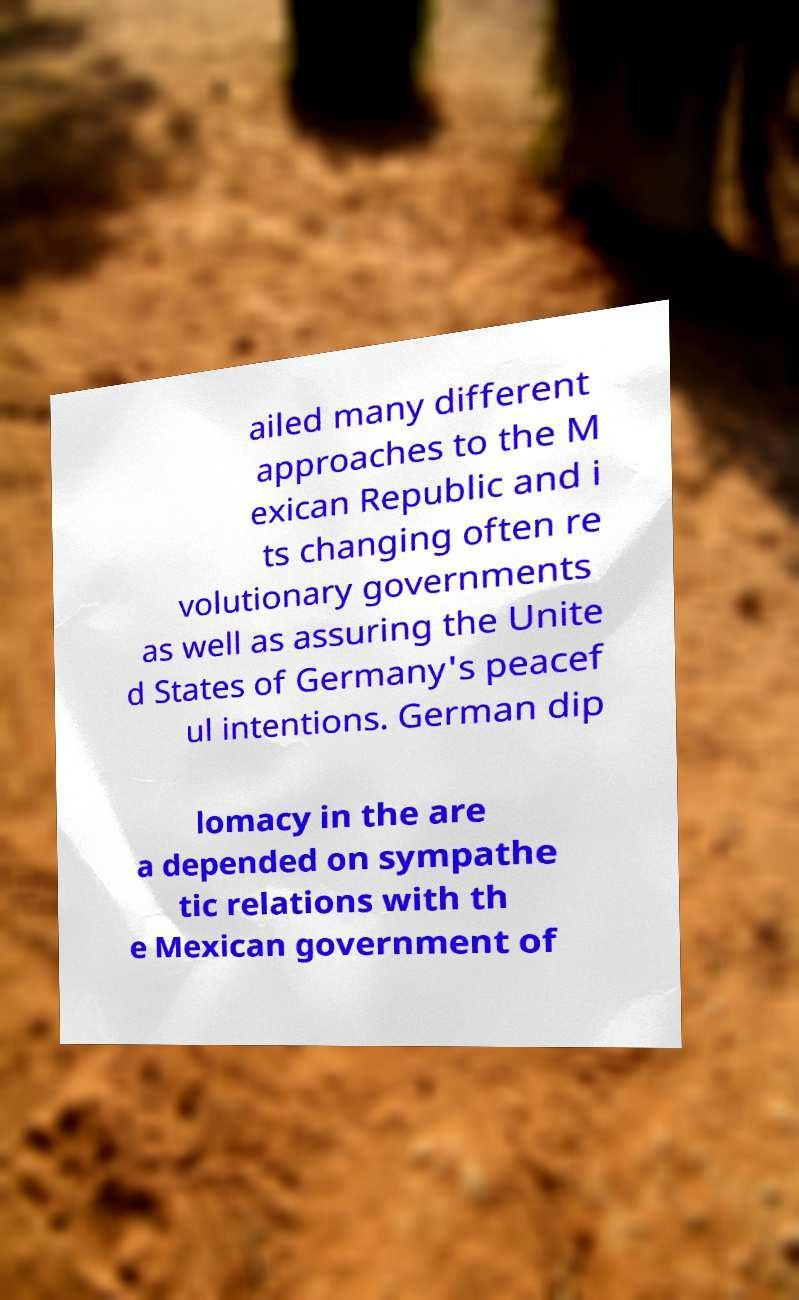Could you assist in decoding the text presented in this image and type it out clearly? ailed many different approaches to the M exican Republic and i ts changing often re volutionary governments as well as assuring the Unite d States of Germany's peacef ul intentions. German dip lomacy in the are a depended on sympathe tic relations with th e Mexican government of 